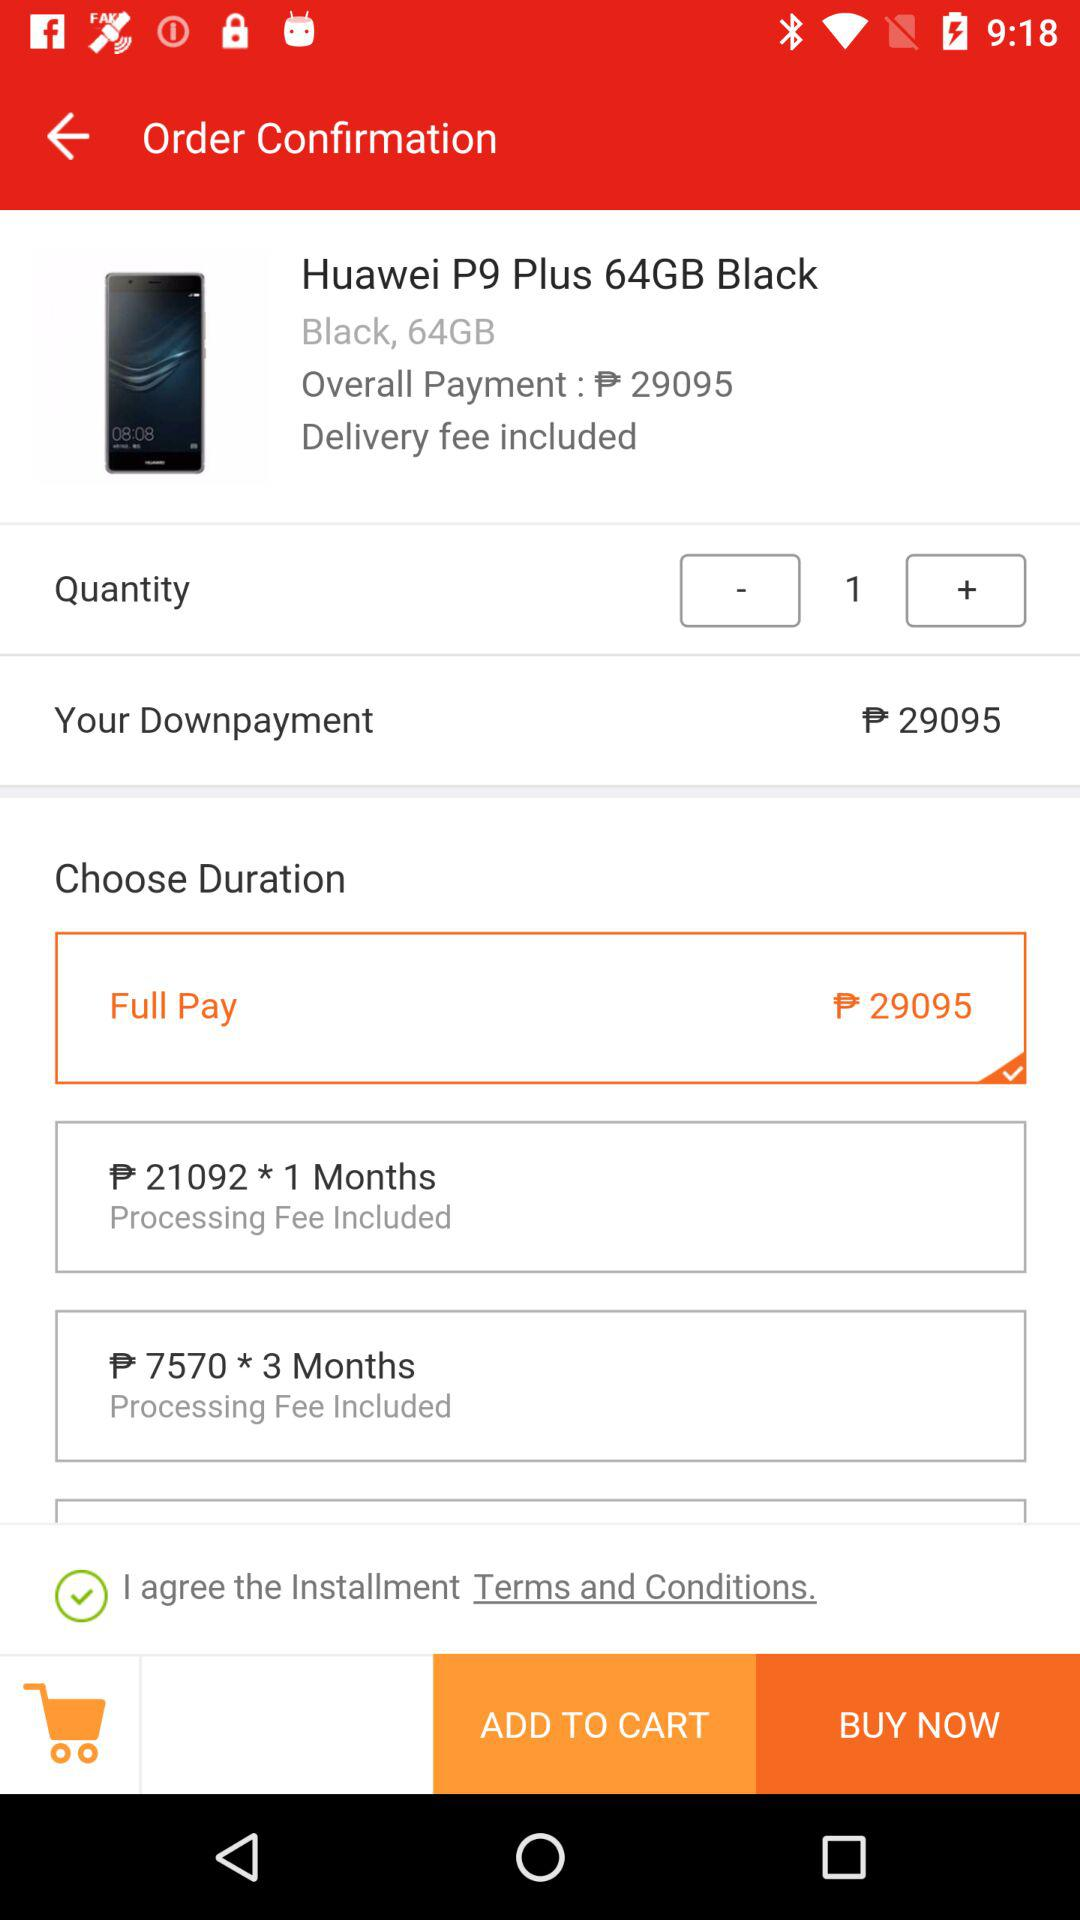What option is selected for duration? The selected option is "Full Pay". 